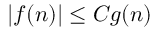<formula> <loc_0><loc_0><loc_500><loc_500>| f ( n ) | \leq C g ( n )</formula> 